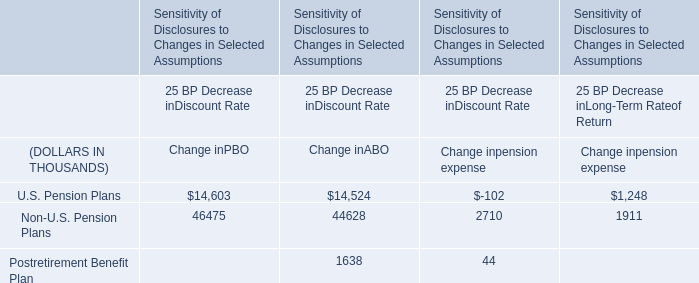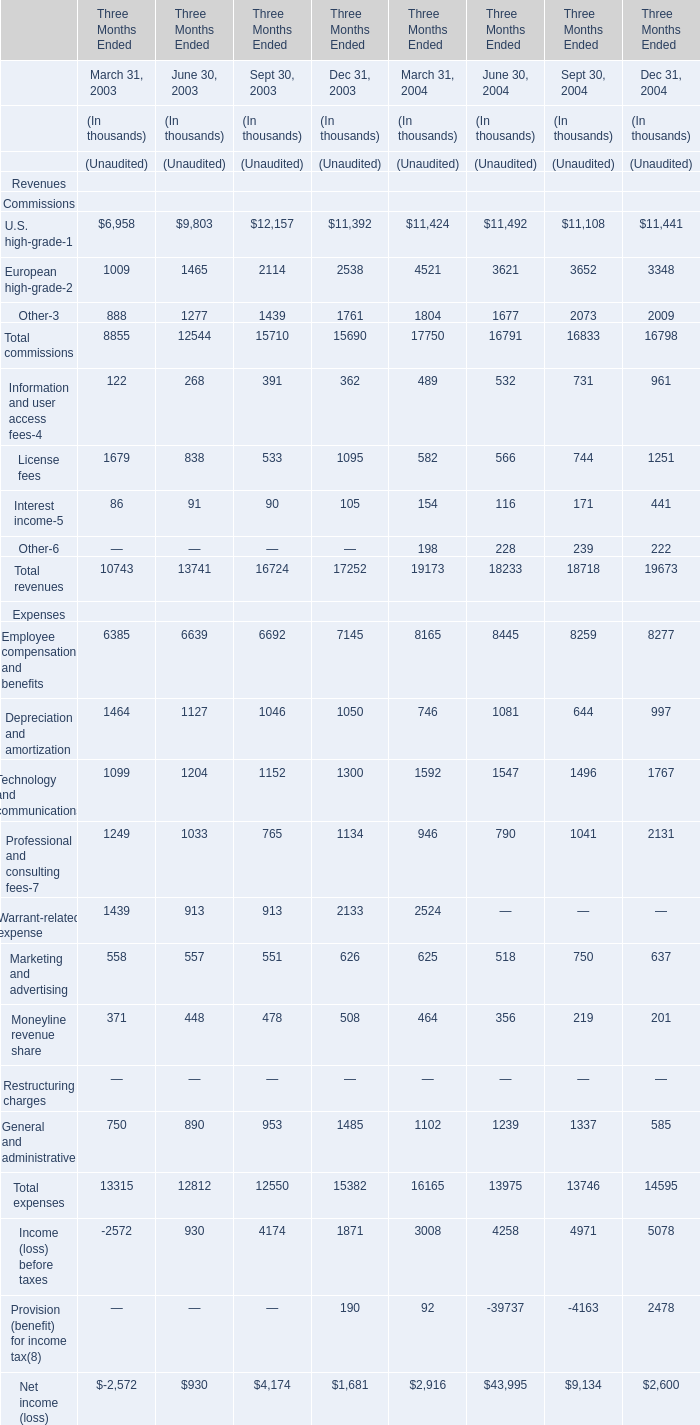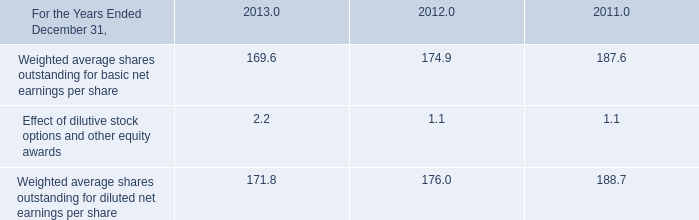What was the total amount of European high-grade-2 and Other-3 for March 31, 2003 ? (in thousand) 
Computations: (1009 + 888)
Answer: 1897.0. 